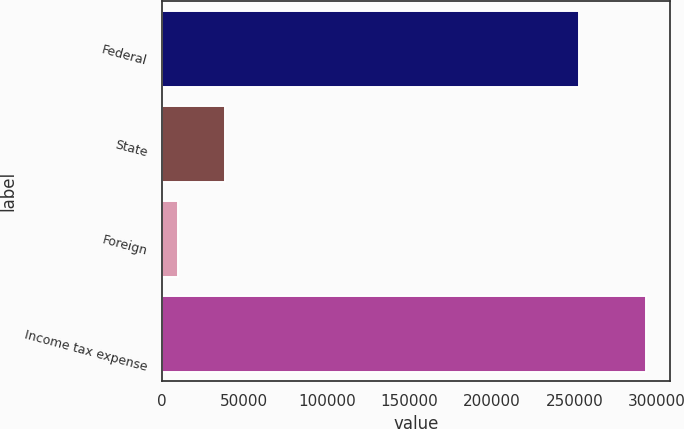<chart> <loc_0><loc_0><loc_500><loc_500><bar_chart><fcel>Federal<fcel>State<fcel>Foreign<fcel>Income tax expense<nl><fcel>252446<fcel>38161<fcel>9814<fcel>293284<nl></chart> 